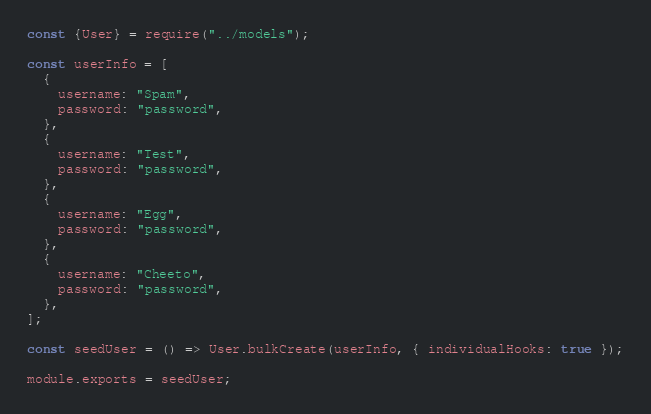Convert code to text. <code><loc_0><loc_0><loc_500><loc_500><_JavaScript_>const {User} = require("../models");

const userInfo = [
  {
    username: "Spam",
    password: "password",
  },
  {
    username: "Test",
    password: "password",
  },
  {
    username: "Egg",
    password: "password",
  },
  {
    username: "Cheeto",
    password: "password",
  },
];

const seedUser = () => User.bulkCreate(userInfo, { individualHooks: true });

module.exports = seedUser;
</code> 